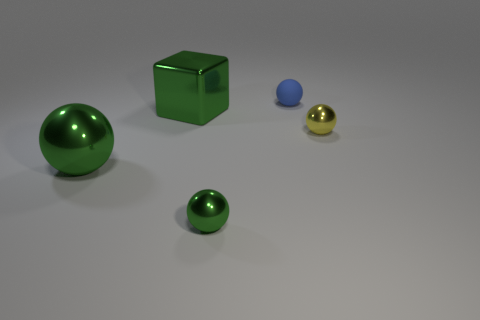What number of other things are there of the same color as the matte ball?
Offer a very short reply. 0. The small object that is to the left of the blue rubber thing has what shape?
Provide a short and direct response. Sphere. Does the small yellow ball have the same material as the small blue sphere?
Offer a very short reply. No. Are there any other things that have the same size as the yellow metallic sphere?
Give a very brief answer. Yes. What number of shiny cubes are to the right of the big green ball?
Your response must be concise. 1. There is a small metal object that is on the left side of the small ball behind the yellow object; what shape is it?
Give a very brief answer. Sphere. Is there anything else that is the same shape as the yellow metal thing?
Ensure brevity in your answer.  Yes. Are there more rubber things that are in front of the big green metal sphere than small red metal spheres?
Offer a very short reply. No. There is a small object that is on the right side of the blue rubber sphere; what number of large green shiny things are behind it?
Your response must be concise. 1. What shape is the object in front of the green shiny object that is left of the big green metallic block left of the tiny matte thing?
Ensure brevity in your answer.  Sphere. 